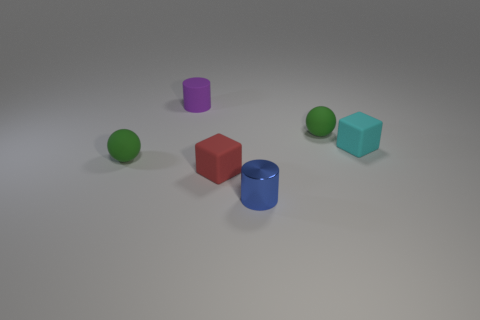How many things are objects that are on the right side of the blue cylinder or objects right of the matte cylinder?
Provide a short and direct response. 4. Are there any other things of the same color as the shiny object?
Your answer should be very brief. No. Are there an equal number of cylinders that are in front of the tiny purple matte thing and tiny cyan things in front of the tiny cyan rubber cube?
Offer a very short reply. No. Are there more small red blocks that are behind the purple rubber cylinder than small blue metallic cylinders?
Ensure brevity in your answer.  No. How many things are either tiny things that are in front of the cyan rubber cube or rubber cylinders?
Keep it short and to the point. 4. What number of small cylinders are made of the same material as the small blue thing?
Provide a succinct answer. 0. Is there another blue thing of the same shape as the tiny blue shiny object?
Give a very brief answer. No. There is a purple object that is the same size as the blue thing; what is its shape?
Offer a very short reply. Cylinder. Do the tiny metallic thing and the rubber block on the left side of the tiny cyan object have the same color?
Give a very brief answer. No. There is a block right of the tiny shiny cylinder; how many green things are in front of it?
Keep it short and to the point. 1. 